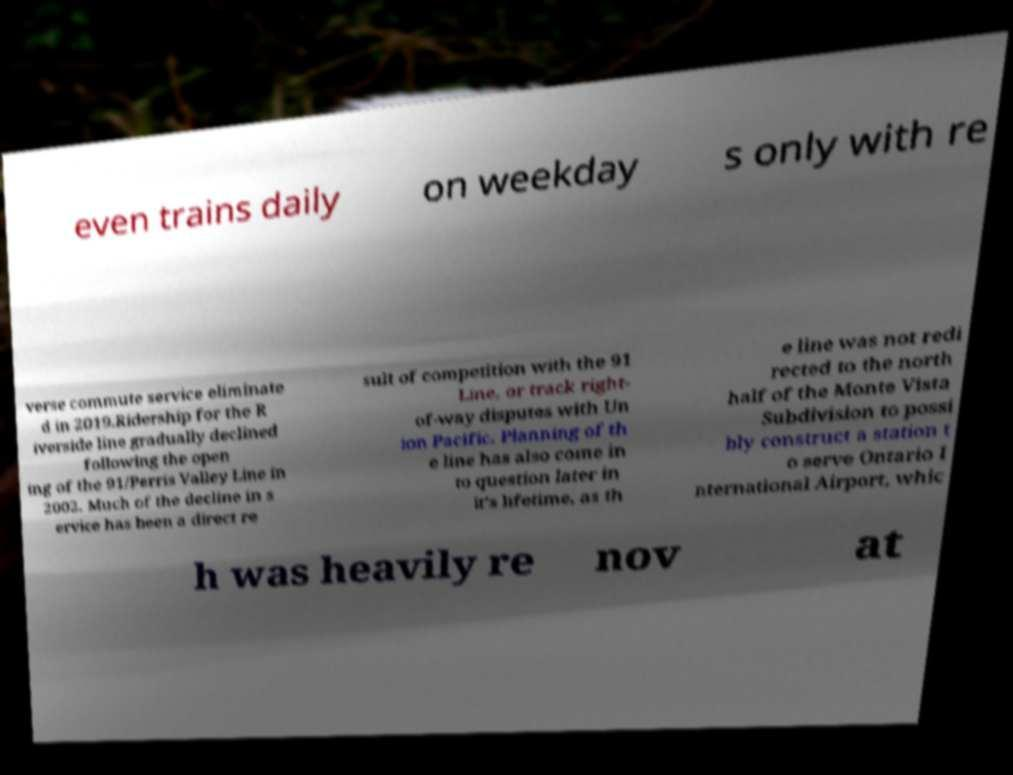Can you accurately transcribe the text from the provided image for me? even trains daily on weekday s only with re verse commute service eliminate d in 2019.Ridership for the R iverside line gradually declined following the open ing of the 91/Perris Valley Line in 2002. Much of the decline in s ervice has been a direct re sult of competition with the 91 Line, or track right- of-way disputes with Un ion Pacific. Planning of th e line has also come in to question later in it’s lifetime, as th e line was not redi rected to the north half of the Monte Vista Subdivision to possi bly construct a station t o serve Ontario I nternational Airport, whic h was heavily re nov at 